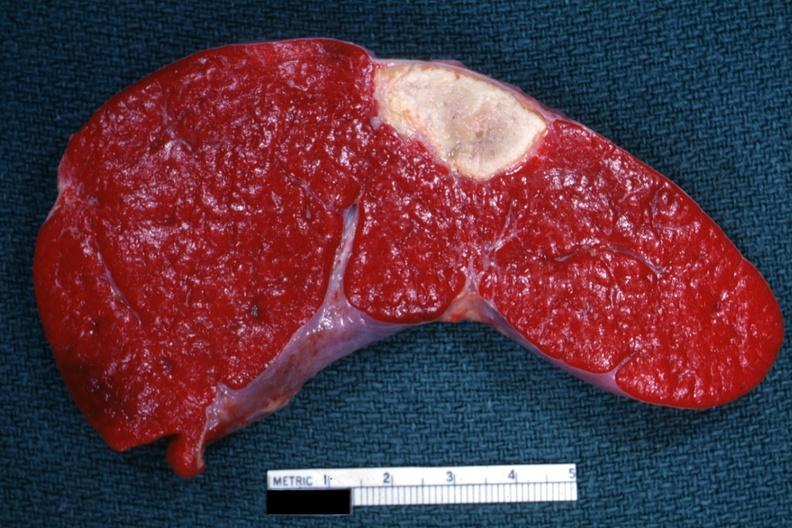what is present?
Answer the question using a single word or phrase. Hematologic 